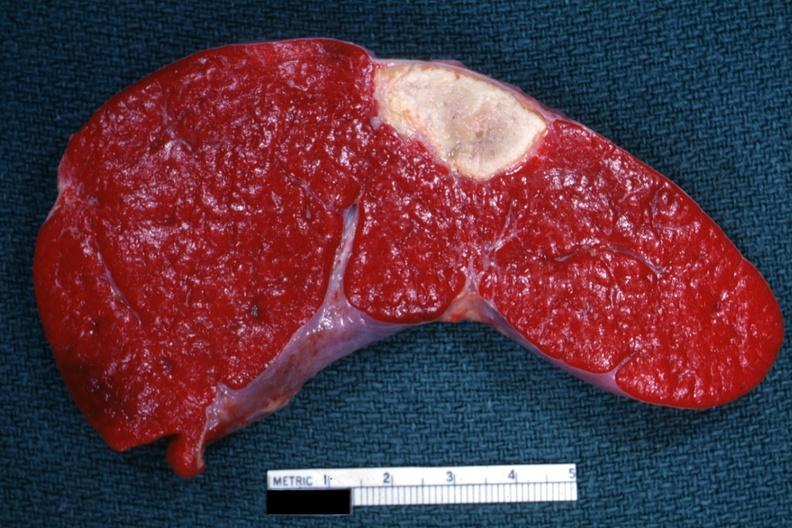what is present?
Answer the question using a single word or phrase. Hematologic 